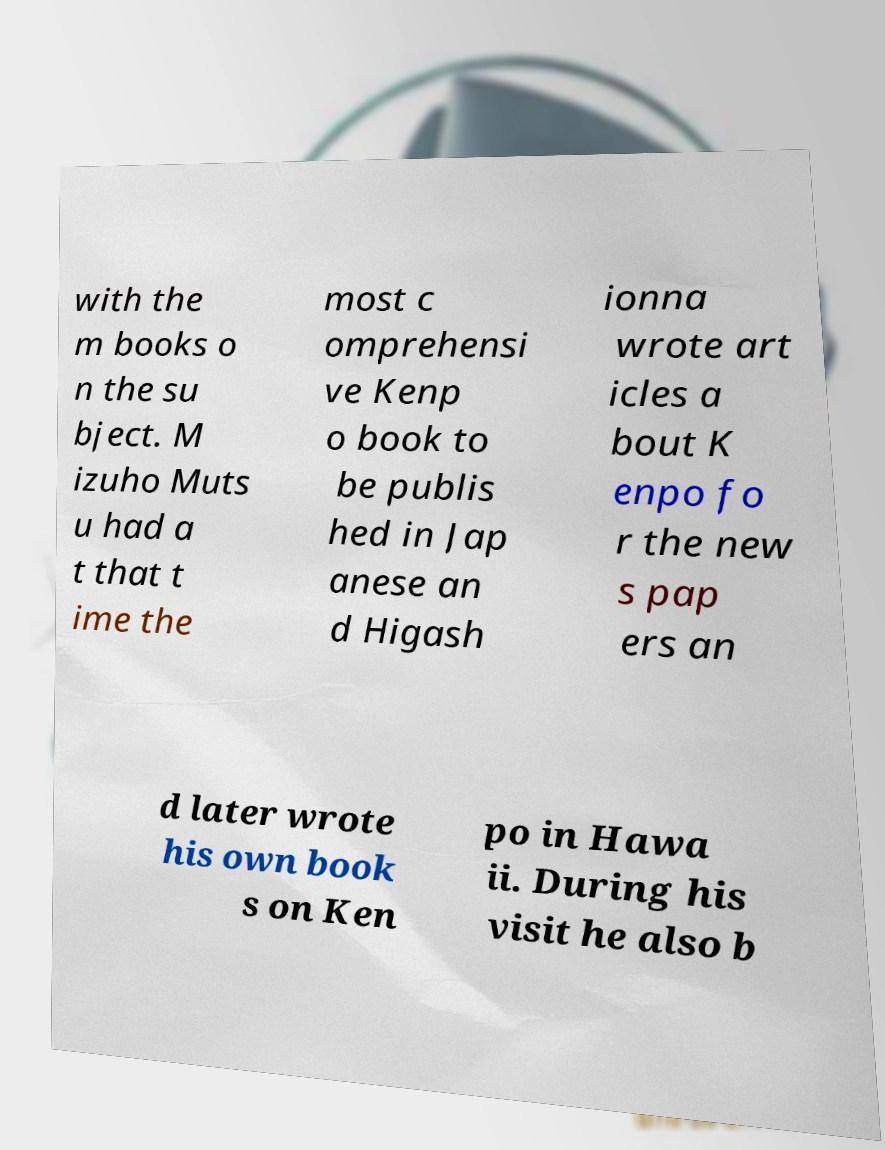Please read and relay the text visible in this image. What does it say? with the m books o n the su bject. M izuho Muts u had a t that t ime the most c omprehensi ve Kenp o book to be publis hed in Jap anese an d Higash ionna wrote art icles a bout K enpo fo r the new s pap ers an d later wrote his own book s on Ken po in Hawa ii. During his visit he also b 